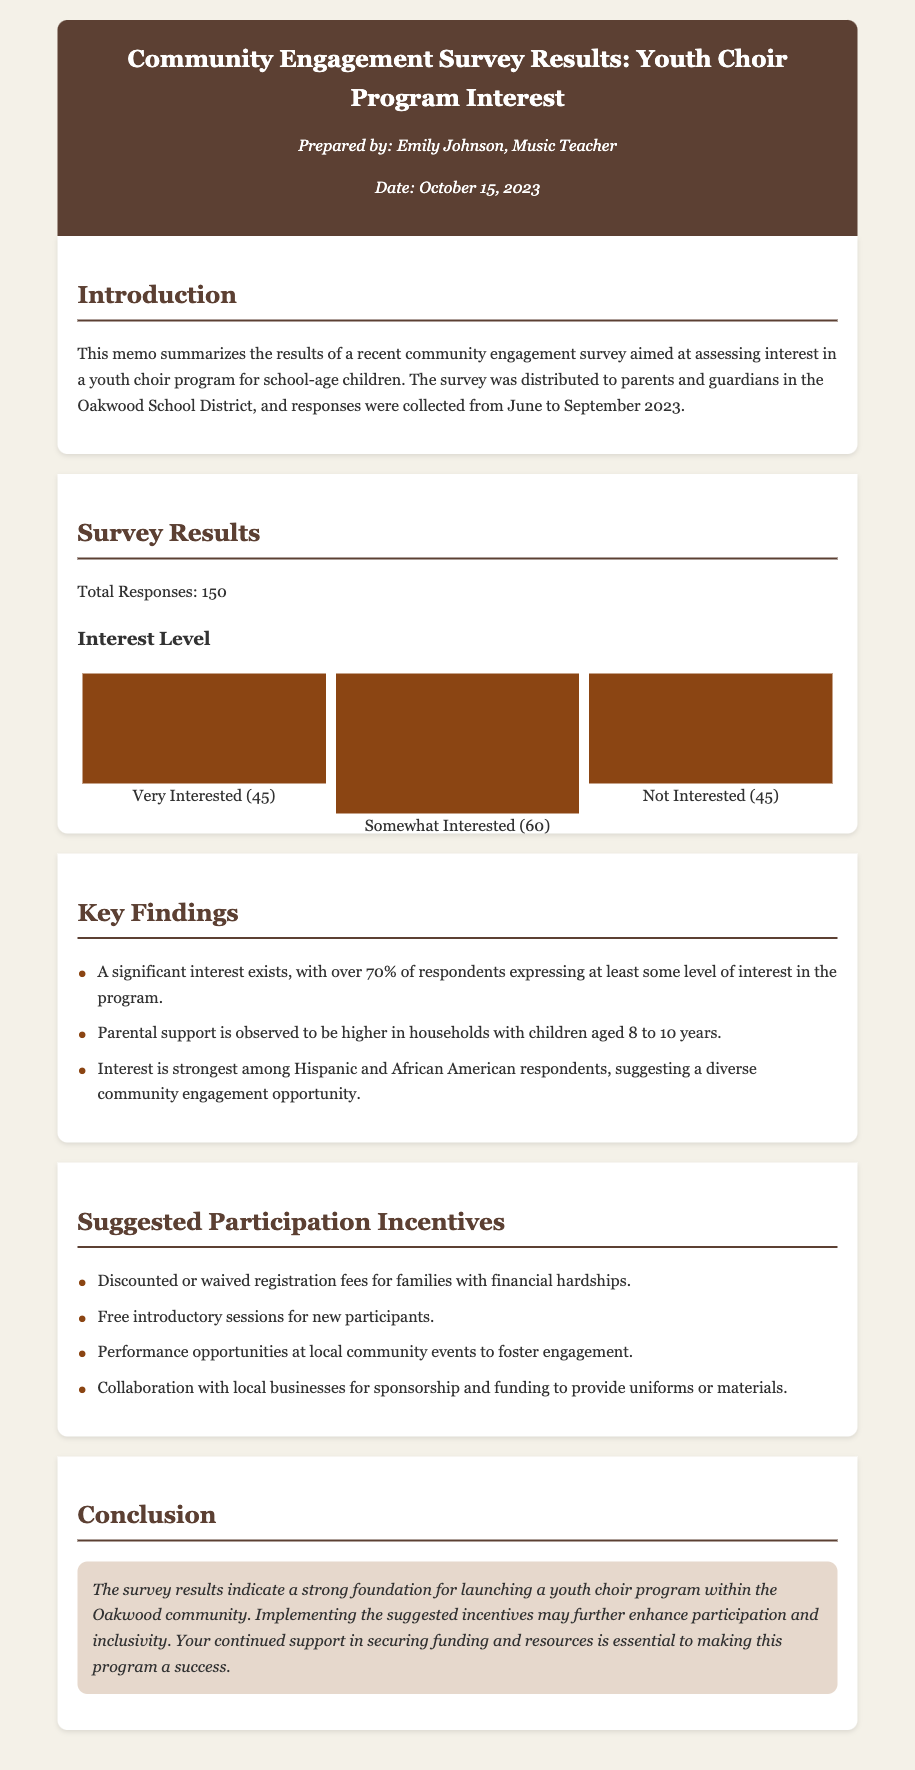What was the total number of survey responses? The total number of survey responses is explicitly stated in the document.
Answer: 150 What percentage of respondents expressed some level of interest? The document notes that over 70% of respondents showed interest in the program.
Answer: Over 70% What is the highest level of interest indicated in the survey results? The highest level of interest is captured in the survey results provided in the visual information.
Answer: Somewhat Interested Which age group showed the highest parental support? The document specifies that parental support is higher in households with children aged 8 to 10 years.
Answer: 8 to 10 years What type of incentives are suggested for participation? The document lists various suggestions under the participation incentives section.
Answer: Discounted registration fees Which demographic groups showed the strongest interest in the choir program? The document mentions specific demographic groups that expressed a stronger interest based on survey results.
Answer: Hispanic and African American When was the survey conducted? The timeframe for the survey collection is mentioned in the introduction section.
Answer: June to September 2023 Who prepared the community engagement survey results memo? The document provides the name of the individual responsible for preparing the memo.
Answer: Emily Johnson What is the purpose of the document? The purpose of the document is outlined in the introduction section.
Answer: To summarize survey results 